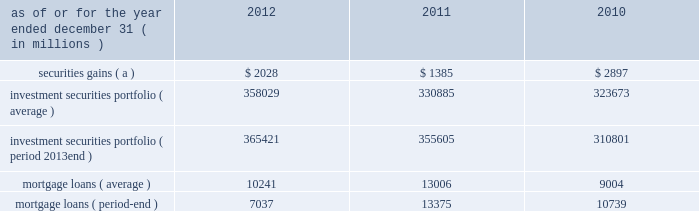Jpmorgan chase & co./2012 annual report 103 2011 compared with 2010 net income was $ 822 million , compared with $ 1.3 billion in the prior year .
Private equity reported net income of $ 391 million , compared with $ 588 million in the prior year .
Net revenue was $ 836 million , a decrease of $ 403 million , primarily related to net write-downs on private investments and the absence of prior year gains on sales .
Noninterest expense was $ 238 million , a decrease of $ 85 million from the prior treasury and cio reported net income of $ 1.3 billion , compared with net income of $ 3.6 billion in the prior year .
Net revenue was $ 3.2 billion , including $ 1.4 billion of security gains .
Net interest income in 2011 was lower compared with 2010 , primarily driven by repositioning of the investment securities portfolio and lower funding benefits from financing the portfolio .
Other corporate reported a net loss of $ 918 million , compared with a net loss of $ 2.9 billion in the prior year .
Net revenue was $ 103 million , compared with a net loss of $ 467 million in the prior year .
Noninterest expense was $ 2.9 billion which included $ 3.2 billion of additional litigation reserves , predominantly for mortgage-related matters .
Noninterest expense in the prior year was $ 5.5 billion which included $ 5.7 billion of additional litigation reserves .
Treasury and cio overview treasury and cio are predominantly responsible for measuring , monitoring , reporting and managing the firm 2019s liquidity , funding , capital and structural interest rate and foreign exchange risks .
The risks managed by treasury and cio arise from the activities undertaken by the firm 2019s four major reportable business segments to serve their respective client bases , which generate both on- and off- balance sheet assets and liabilities .
Treasury is responsible for , among other functions , funds transfer pricing .
Funds transfer pricing is used to transfer structural interest rate risk and foreign exchange risk of the firm to treasury and cio and allocate interest income and expense to each business based on market rates .
Cio , through its management of the investment portfolio , generates net interest income to pay the lines of business market rates .
Any variance ( whether positive or negative ) between amounts generated by cio through its investment portfolio activities and amounts paid to or received by the lines of business are retained by cio , and are not reflected in line of business segment results .
Treasury and cio activities operate in support of the overall firm .
Cio achieves the firm 2019s asset-liability management objectives generally by investing in high-quality securities that are managed for the longer-term as part of the firm 2019s afs investment portfolio .
Unrealized gains and losses on securities held in the afs portfolio are recorded in other comprehensive income .
For further information about securities in the afs portfolio , see note 3 and note 12 on pages 196 2013214 and 244 2013248 , respectively , of this annual report .
Cio also uses securities that are not classified within the afs portfolio , as well as derivatives , to meet the firm 2019s asset-liability management objectives .
Securities not classified within the afs portfolio are recorded in trading assets and liabilities ; realized and unrealized gains and losses on such securities are recorded in the principal transactions revenue line in the consolidated statements of income .
For further information about securities included in trading assets and liabilities , see note 3 on pages 196 2013214 of this annual report .
Derivatives used by cio are also classified as trading assets and liabilities .
For further information on derivatives , including the classification of realized and unrealized gains and losses , see note 6 on pages 218 2013227 of this annual report .
Cio 2019s afs portfolio consists of u.s .
And non-u.s .
Government securities , agency and non-agency mortgage-backed securities , other asset-backed securities and corporate and municipal debt securities .
Treasury 2019s afs portfolio consists of u.s .
And non-u.s .
Government securities and corporate debt securities .
At december 31 , 2012 , the total treasury and cio afs portfolios were $ 344.1 billion and $ 21.3 billion , respectively ; the average credit rating of the securities comprising the treasury and cio afs portfolios was aa+ ( based upon external ratings where available and where not available , based primarily upon internal ratings that correspond to ratings as defined by s&p and moody 2019s ) .
See note 12 on pages 244 2013248 of this annual report for further information on the details of the firm 2019s afs portfolio .
For further information on liquidity and funding risk , see liquidity risk management on pages 127 2013133 of this annual report .
For information on interest rate , foreign exchange and other risks , and cio var and the firm 2019s nontrading interest rate-sensitive revenue at risk , see market risk management on pages 163 2013169 of this annual report .
Selected income statement and balance sheet data as of or for the year ended december 31 , ( in millions ) 2012 2011 2010 securities gains ( a ) $ 2028 $ 1385 $ 2897 investment securities portfolio ( average ) 358029 330885 323673 investment securities portfolio ( period 2013end ) 365421 355605 310801 .
( a ) reflects repositioning of the investment securities portfolio. .
Would would 2011 net income have been without the private equity segment ( in millions ) ? 
Computations: (822 - 391)
Answer: 431.0. 